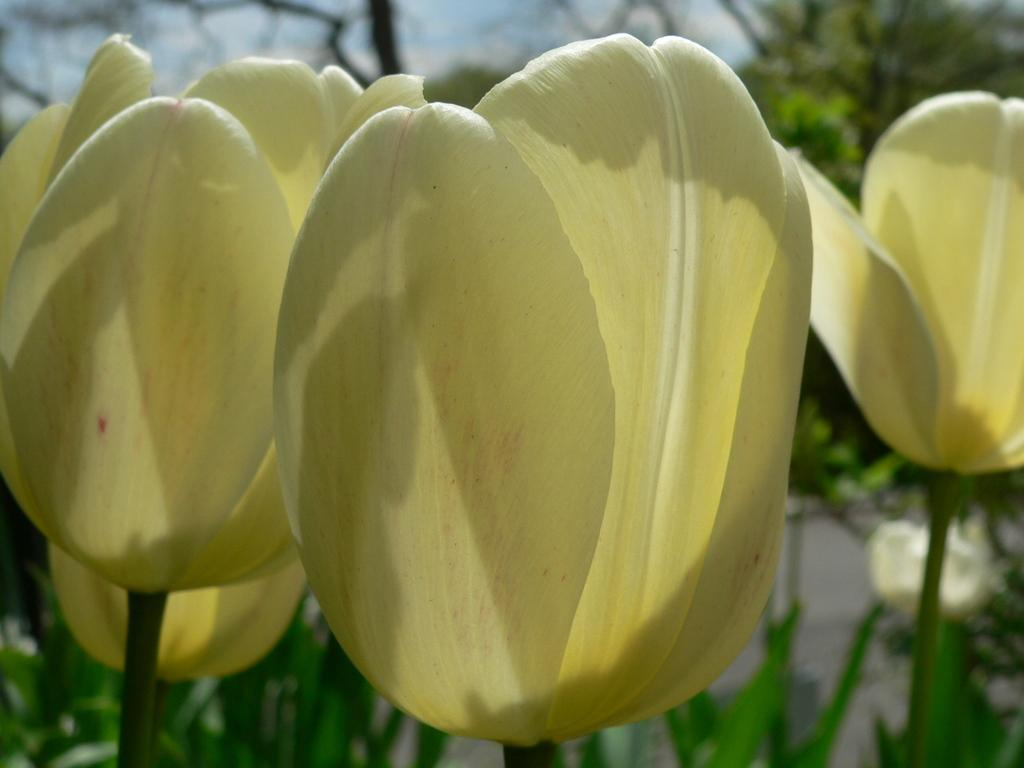What is the main subject in the center of the image? There are tulips in the center of the image. What color are the tulips? The tulips are yellow in color. What else can be seen at the bottom of the image? There are plants at the bottom of the image. How does the image cover the volcano in the background? There is no volcano present in the image, so it cannot cover something that is not there. 